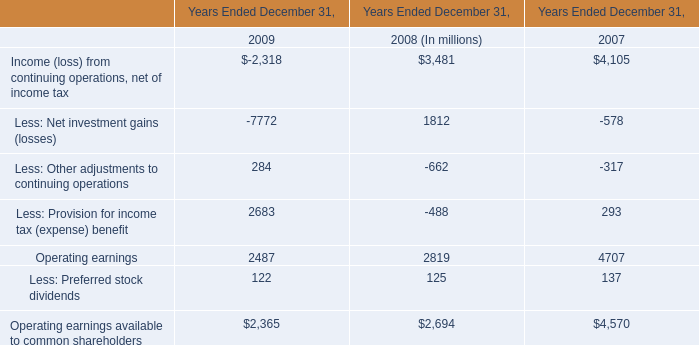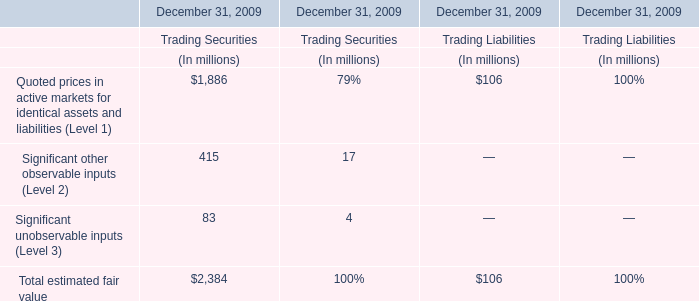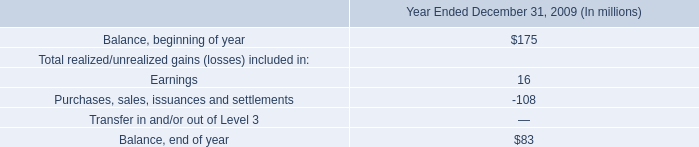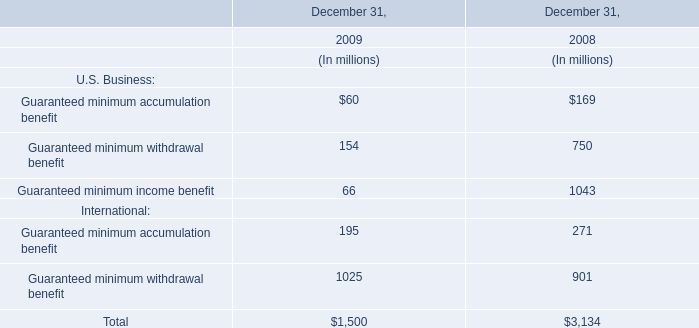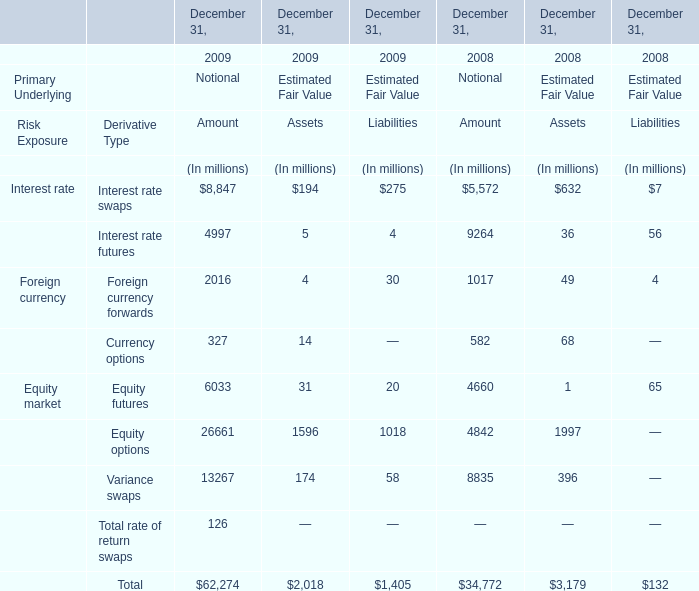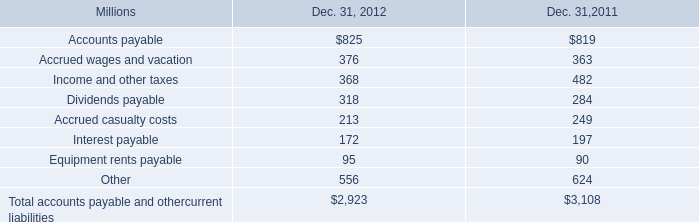As As the chart 4 shows, what is the Estimated Fair Value of the Assets for the Derivative Type:Interest rate futures for December 31,2009 ? (in million) 
Answer: 5. 